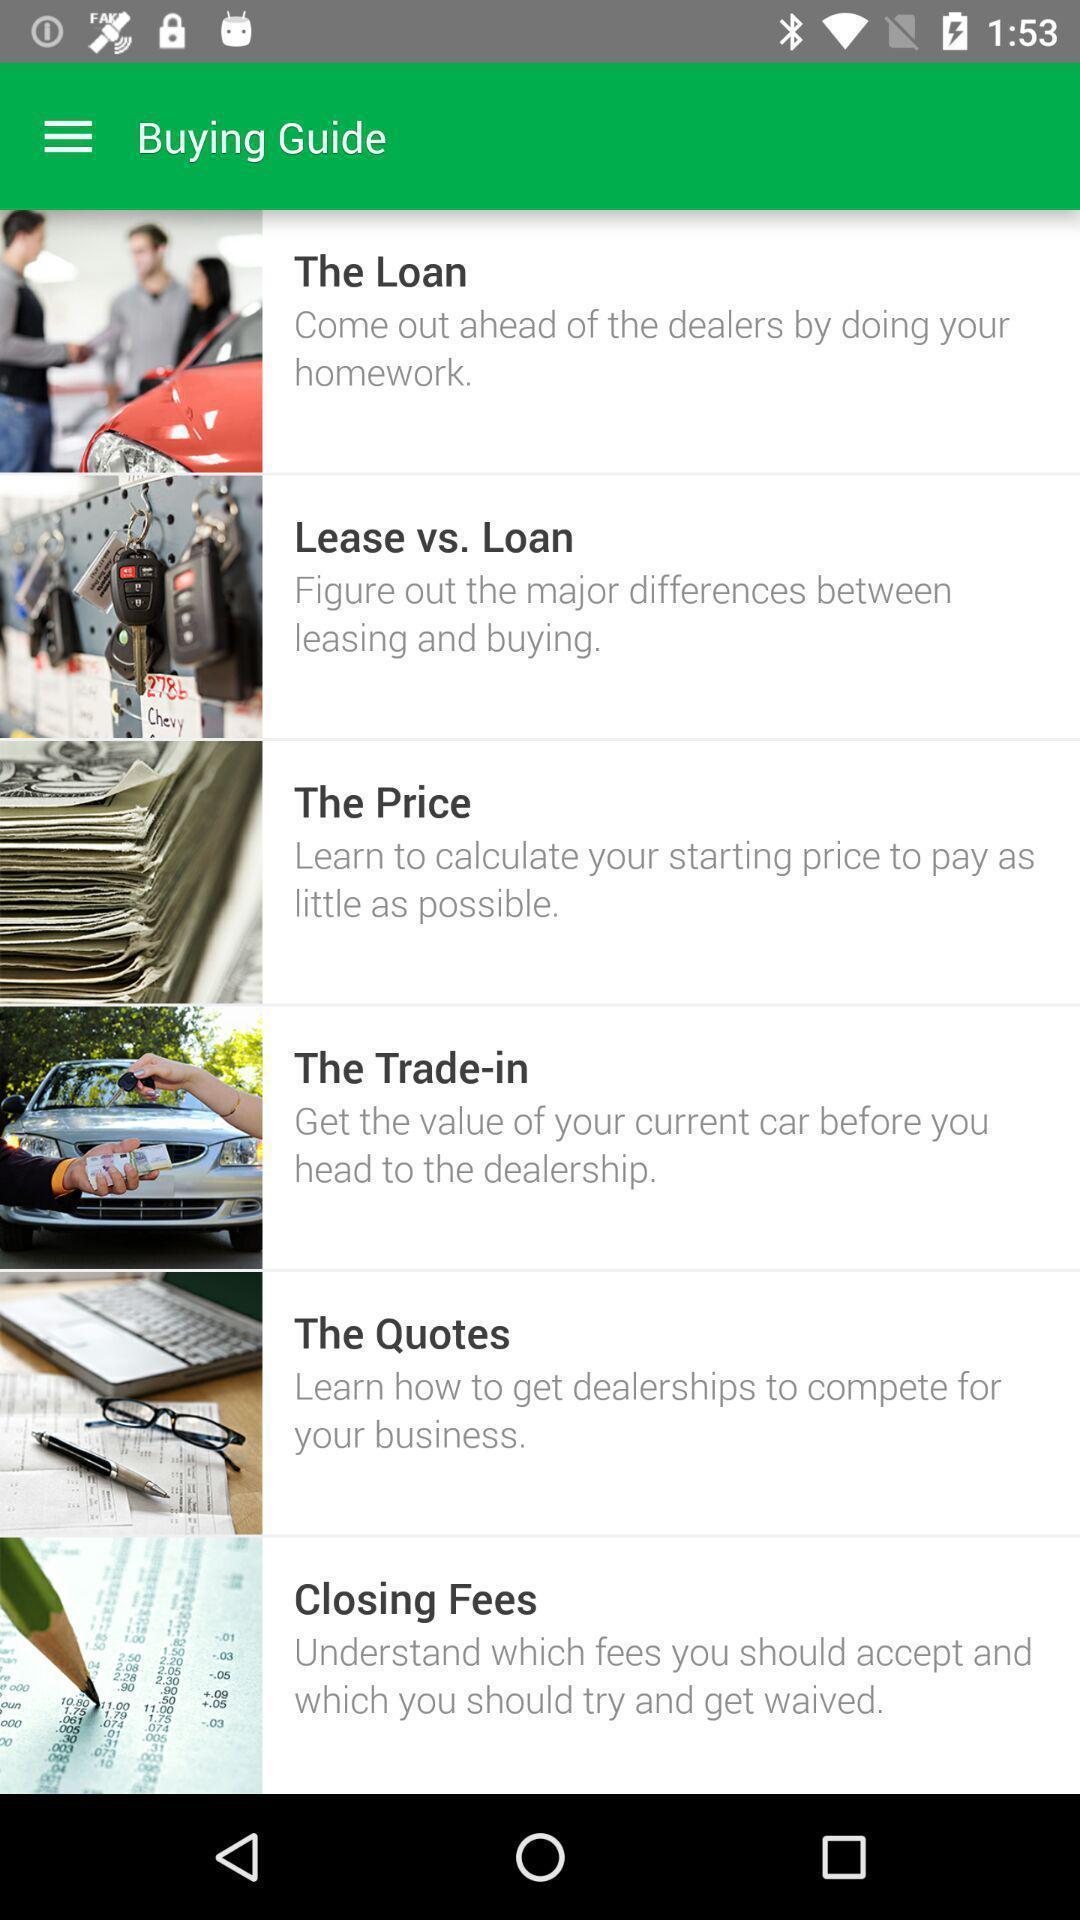Describe the content in this image. Screen displaying the buying guide page. 